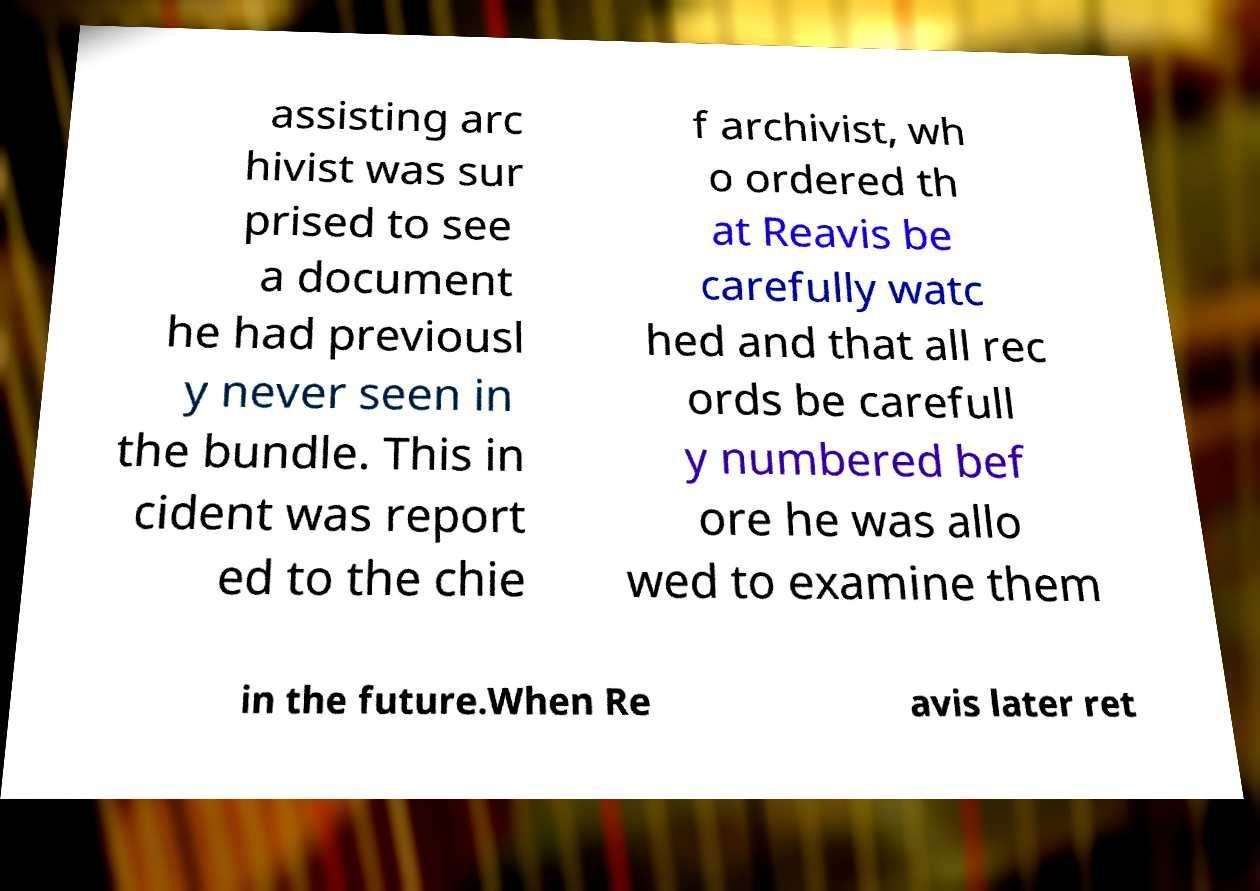What messages or text are displayed in this image? I need them in a readable, typed format. assisting arc hivist was sur prised to see a document he had previousl y never seen in the bundle. This in cident was report ed to the chie f archivist, wh o ordered th at Reavis be carefully watc hed and that all rec ords be carefull y numbered bef ore he was allo wed to examine them in the future.When Re avis later ret 